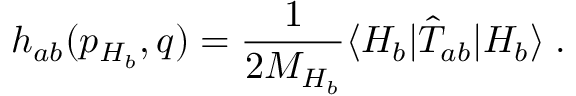<formula> <loc_0><loc_0><loc_500><loc_500>h _ { a b } ( p _ { H _ { b } } , q ) = \frac { 1 } { 2 M _ { H _ { b } } } \langle H _ { b } | \hat { T } _ { a b } | H _ { b } \rangle \, .</formula> 